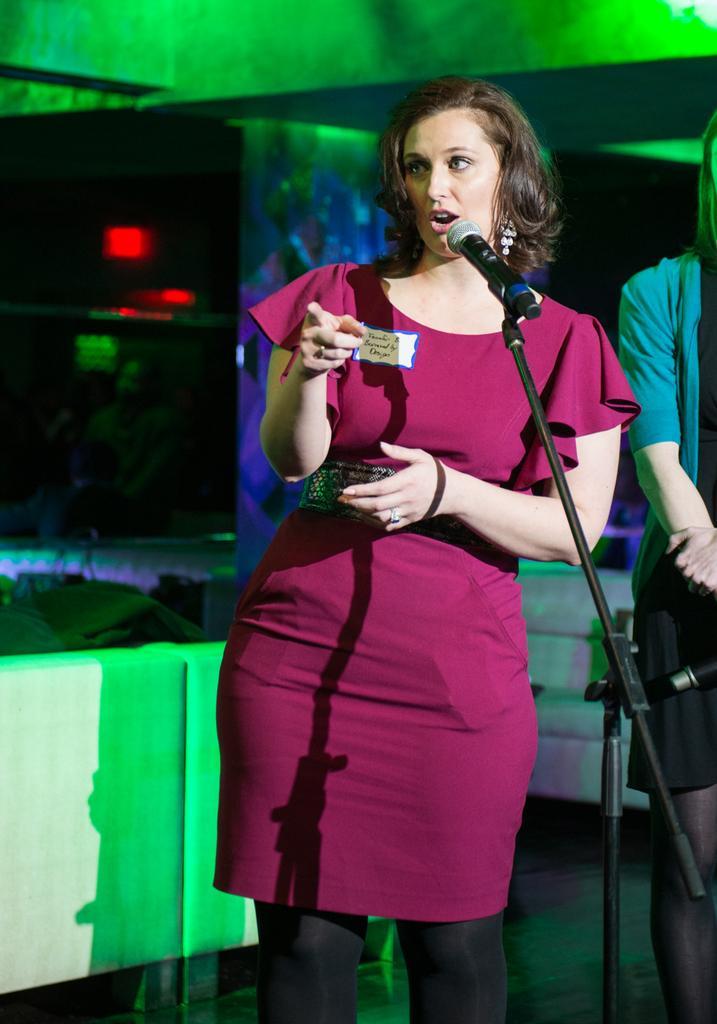Please provide a concise description of this image. This is a picture taken in a meeting. In the foreground of the picture there is a woman in red dress. In front of her there is a microphone, she is wearing red dress and she is standing. On the right there is another person standing. In the background there are couches. At the top it is well. The room is in with green lights. 